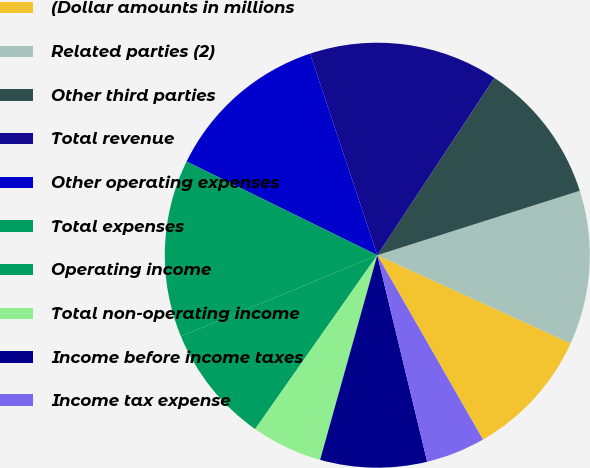<chart> <loc_0><loc_0><loc_500><loc_500><pie_chart><fcel>(Dollar amounts in millions<fcel>Related parties (2)<fcel>Other third parties<fcel>Total revenue<fcel>Other operating expenses<fcel>Total expenses<fcel>Operating income<fcel>Total non-operating income<fcel>Income before income taxes<fcel>Income tax expense<nl><fcel>9.91%<fcel>11.71%<fcel>10.81%<fcel>14.41%<fcel>12.61%<fcel>13.51%<fcel>9.01%<fcel>5.41%<fcel>8.11%<fcel>4.51%<nl></chart> 